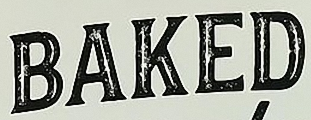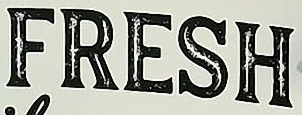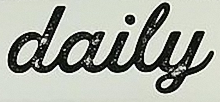What text is displayed in these images sequentially, separated by a semicolon? BAKED; FRESH; daily 